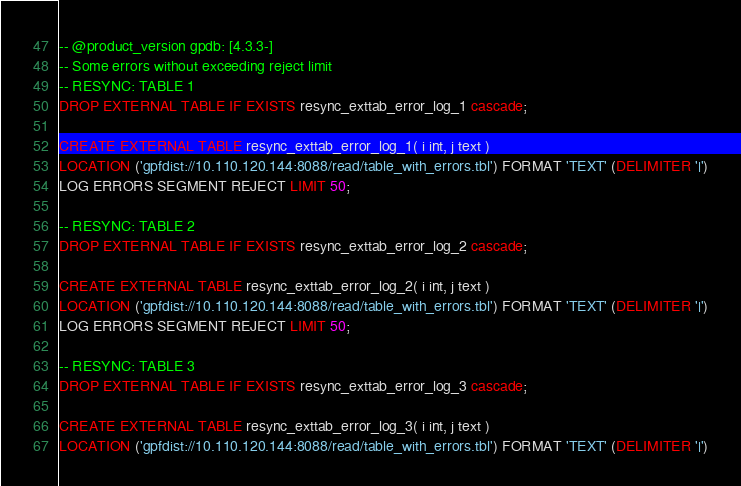Convert code to text. <code><loc_0><loc_0><loc_500><loc_500><_SQL_>-- @product_version gpdb: [4.3.3-]
-- Some errors without exceeding reject limit
-- RESYNC: TABLE 1
DROP EXTERNAL TABLE IF EXISTS resync_exttab_error_log_1 cascade;

CREATE EXTERNAL TABLE resync_exttab_error_log_1( i int, j text )
LOCATION ('gpfdist://10.110.120.144:8088/read/table_with_errors.tbl') FORMAT 'TEXT' (DELIMITER '|')
LOG ERRORS SEGMENT REJECT LIMIT 50;

-- RESYNC: TABLE 2
DROP EXTERNAL TABLE IF EXISTS resync_exttab_error_log_2 cascade;

CREATE EXTERNAL TABLE resync_exttab_error_log_2( i int, j text )
LOCATION ('gpfdist://10.110.120.144:8088/read/table_with_errors.tbl') FORMAT 'TEXT' (DELIMITER '|')
LOG ERRORS SEGMENT REJECT LIMIT 50;

-- RESYNC: TABLE 3
DROP EXTERNAL TABLE IF EXISTS resync_exttab_error_log_3 cascade;

CREATE EXTERNAL TABLE resync_exttab_error_log_3( i int, j text )
LOCATION ('gpfdist://10.110.120.144:8088/read/table_with_errors.tbl') FORMAT 'TEXT' (DELIMITER '|')</code> 